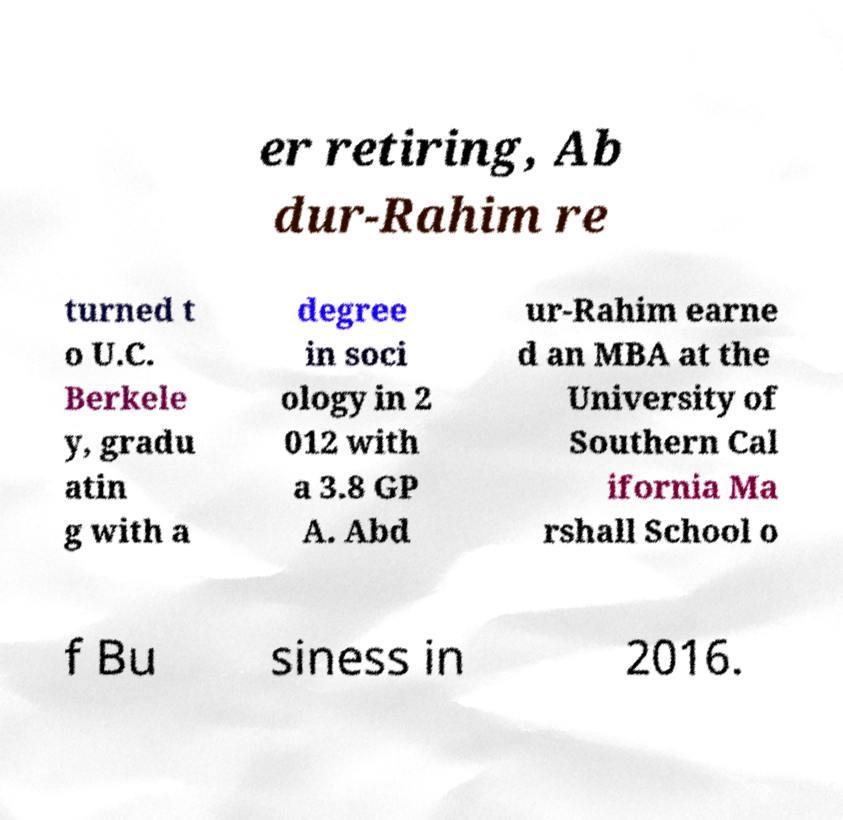Can you read and provide the text displayed in the image?This photo seems to have some interesting text. Can you extract and type it out for me? er retiring, Ab dur-Rahim re turned t o U.C. Berkele y, gradu atin g with a degree in soci ology in 2 012 with a 3.8 GP A. Abd ur-Rahim earne d an MBA at the University of Southern Cal ifornia Ma rshall School o f Bu siness in 2016. 